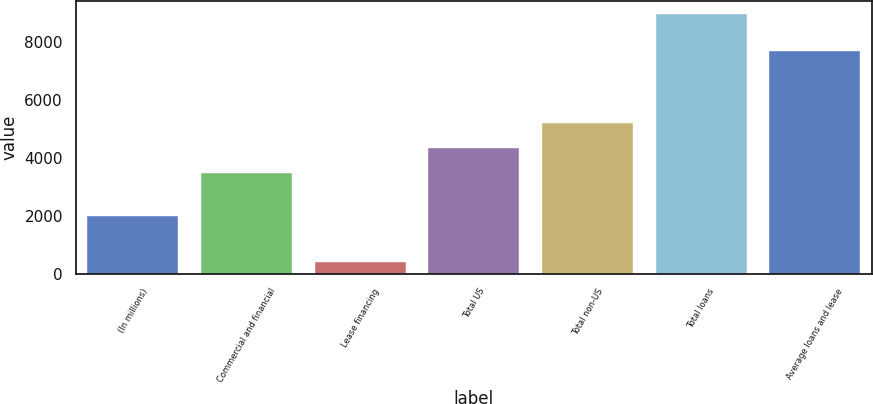<chart> <loc_0><loc_0><loc_500><loc_500><bar_chart><fcel>(In millions)<fcel>Commercial and financial<fcel>Lease financing<fcel>Total US<fcel>Total non-US<fcel>Total loans<fcel>Average loans and lease<nl><fcel>2006<fcel>3480<fcel>415<fcel>4333.1<fcel>5186.2<fcel>8946<fcel>7670<nl></chart> 